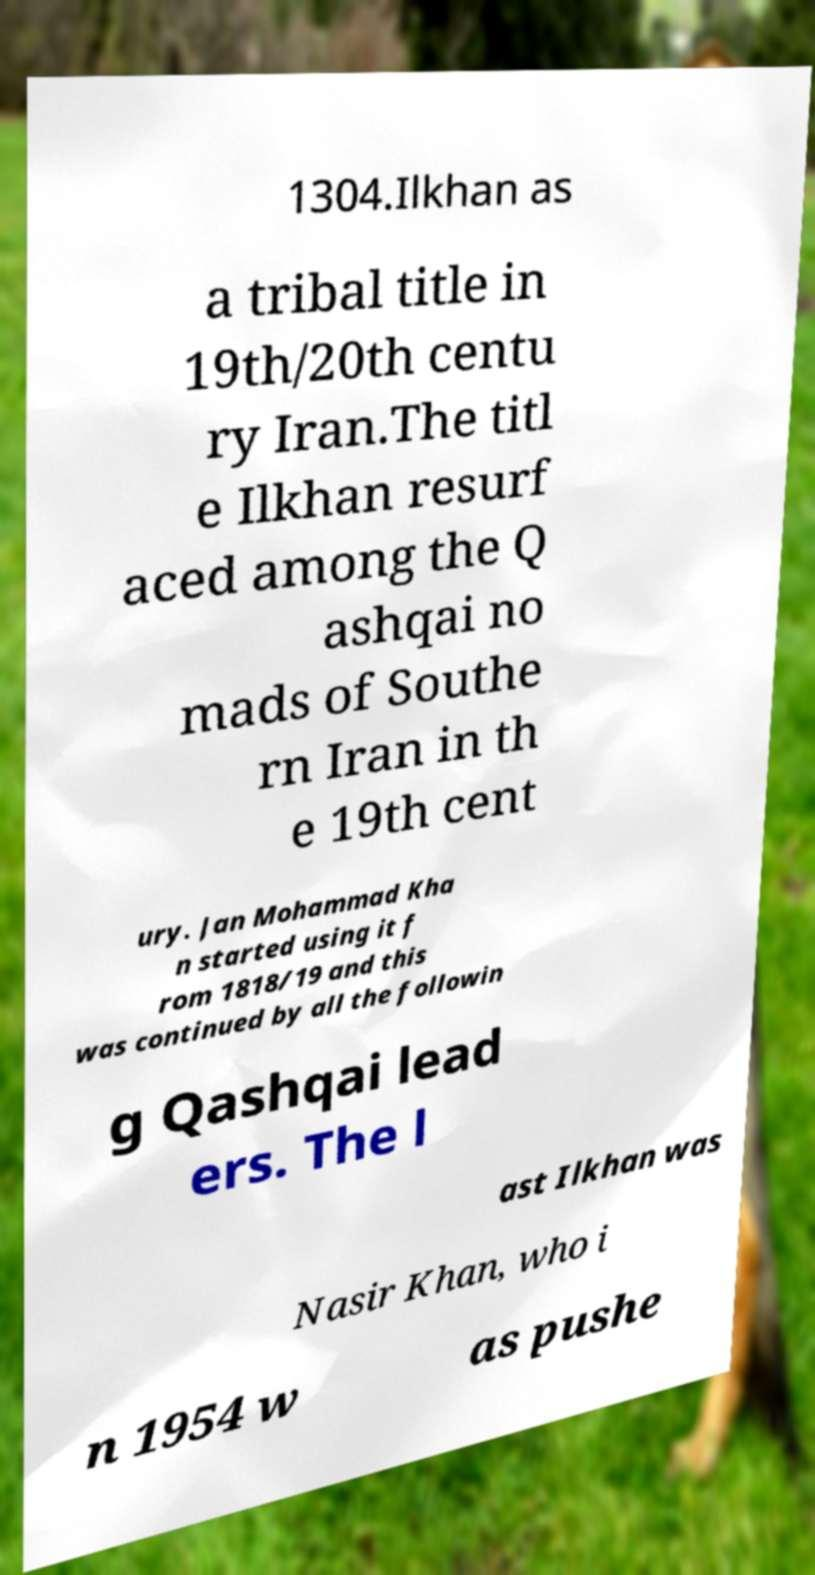I need the written content from this picture converted into text. Can you do that? 1304.Ilkhan as a tribal title in 19th/20th centu ry Iran.The titl e Ilkhan resurf aced among the Q ashqai no mads of Southe rn Iran in th e 19th cent ury. Jan Mohammad Kha n started using it f rom 1818/19 and this was continued by all the followin g Qashqai lead ers. The l ast Ilkhan was Nasir Khan, who i n 1954 w as pushe 